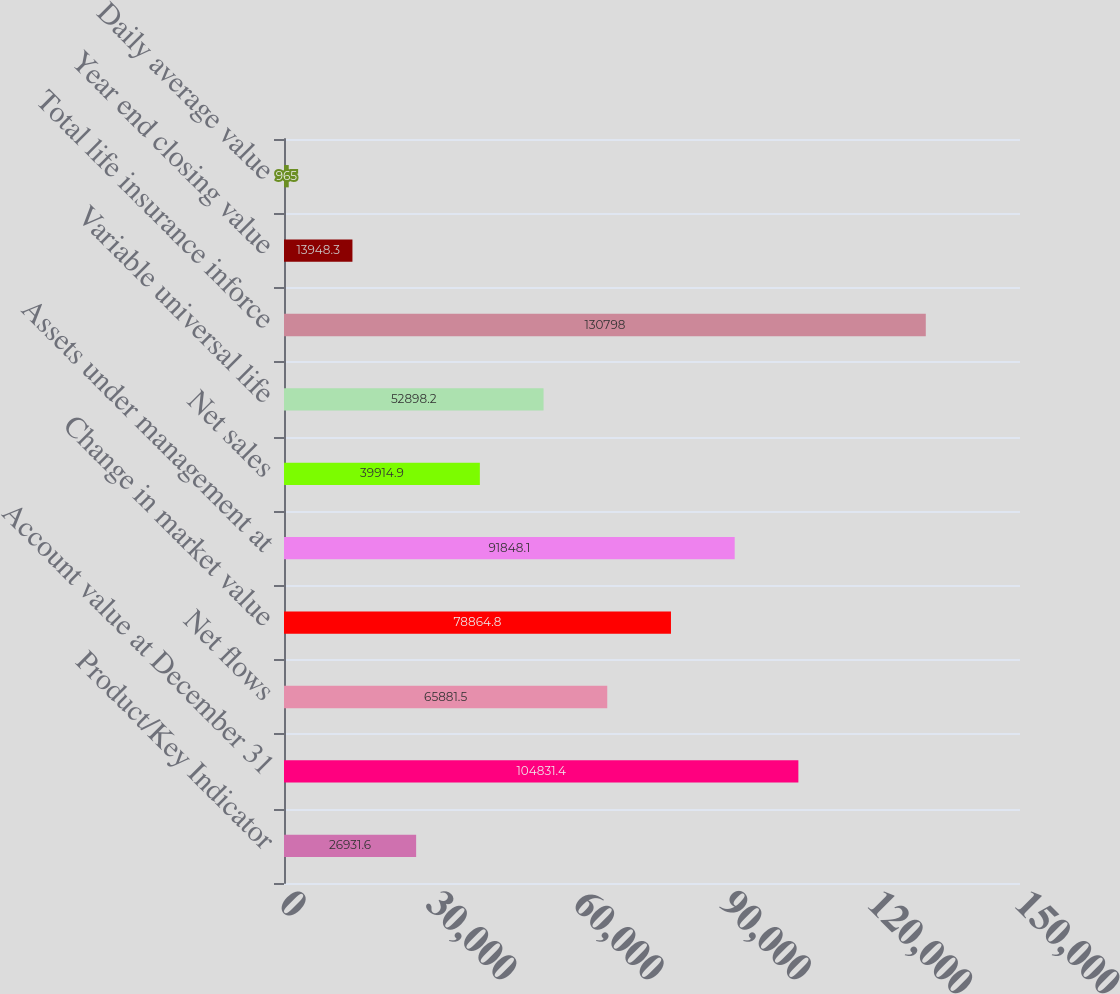<chart> <loc_0><loc_0><loc_500><loc_500><bar_chart><fcel>Product/Key Indicator<fcel>Account value at December 31<fcel>Net flows<fcel>Change in market value<fcel>Assets under management at<fcel>Net sales<fcel>Variable universal life<fcel>Total life insurance inforce<fcel>Year end closing value<fcel>Daily average value<nl><fcel>26931.6<fcel>104831<fcel>65881.5<fcel>78864.8<fcel>91848.1<fcel>39914.9<fcel>52898.2<fcel>130798<fcel>13948.3<fcel>965<nl></chart> 